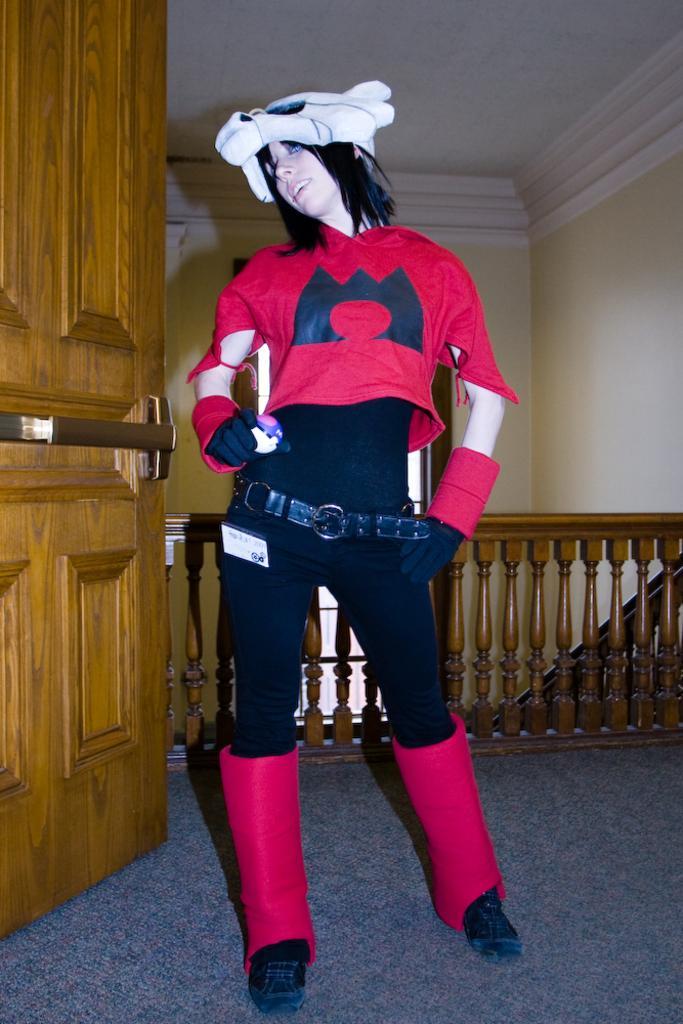How would you summarize this image in a sentence or two? There is a woman in red color t-shirt smiling and standing on the floor. On the left side, there is a wooden door. In the background, there is a wooden fencing, there is a white color ceiling and there is a wall. 